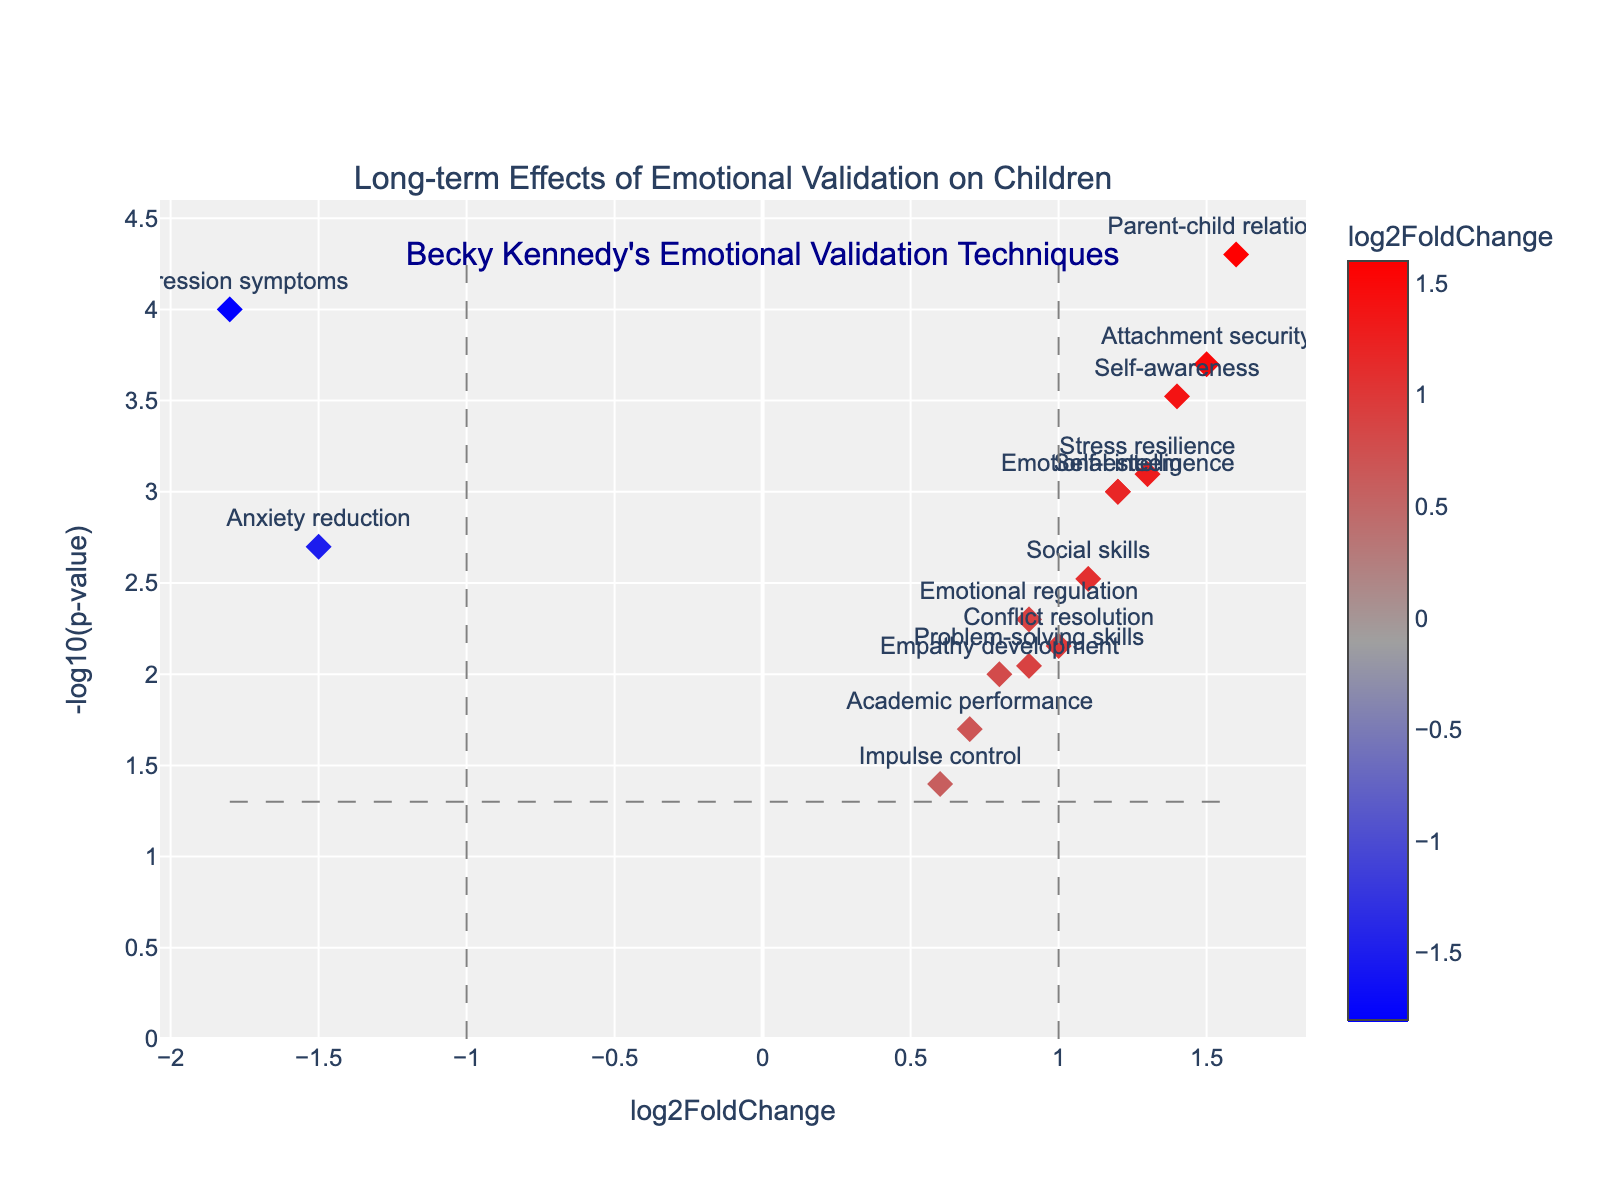What is the title of the plot? The title of the plot is positioned at the top center of the figure. It is labeled as "Long-term Effects of Emotional Validation on Children."
Answer: Long-term Effects of Emotional Validation on Children Which data point has the highest -log10(p-value)? By looking at the y-axis, which represents the -log10(p-value), and finding the highest point, you can see that "Parent-child relationship" has the highest -log10(p-value).
Answer: Parent-child relationship How many data points have a log2FoldChange greater than 1? You can determine this by identifying the data points that are located to the right of the vertical line at log2FoldChange = 1. According to the plot, there are 6 data points: Stress resilience, Parent-child relationship, Self-awareness, Emotional intelligence, Attachment security, and Self-esteem.
Answer: 6 How does "Anxiety reduction" compare to "Self-esteem" in terms of log2FoldChange? First, identify the positions of "Anxiety reduction" and "Self-esteem" on the x-axis which represents log2FoldChange. "Anxiety reduction" has a log2FoldChange of -1.5, and "Self-esteem" has a log2FoldChange of 1.2. Comparatively, "Self-esteem" has a higher log2FoldChange.
Answer: Self-esteem has a higher log2FoldChange What is the log2FoldChange of "Academic performance," and is it above or below the threshold at log2FoldChange 1? Identify the placement of "Academic performance" on the x-axis. "Academic performance" has a log2FoldChange of 0.7. Since 0.7 is below the threshold value of 1, it is below the threshold.
Answer: 0.7, below the threshold How many data points have a -log10(p-value) equal to or greater than 3? To determine this, look for data points that are positioned at or above 3 on the y-axis. There are 4 such data points: Parent-child relationship, Depression symptoms, Attachment security, and Self-awareness.
Answer: 4 Which data point is closest to the log2FoldChange threshold of -1? Find the data point nearest to the vertical line at log2FoldChange = -1. The closest data point is "Anxiety reduction" with a log2FoldChange of -1.5, but it’s the nearest neighbor to -1 in terms of value.
Answer: Anxiety reduction Is "Impulse control" statistically significant, assuming a significance level of p < 0.05? To determine statistical significance, convert the p-value threshold (0.05) to -log10 scale, which is approximately 1.3. Check if "Impulse control" lies above this value on the y-axis. "Impulse control" has a -log10(p-value) less than 1.3, so it is not statistically significant.
Answer: No 